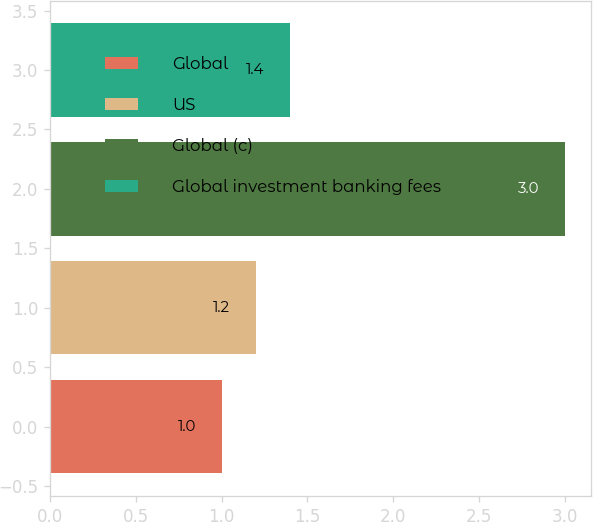<chart> <loc_0><loc_0><loc_500><loc_500><bar_chart><fcel>Global<fcel>US<fcel>Global (c)<fcel>Global investment banking fees<nl><fcel>1<fcel>1.2<fcel>3<fcel>1.4<nl></chart> 